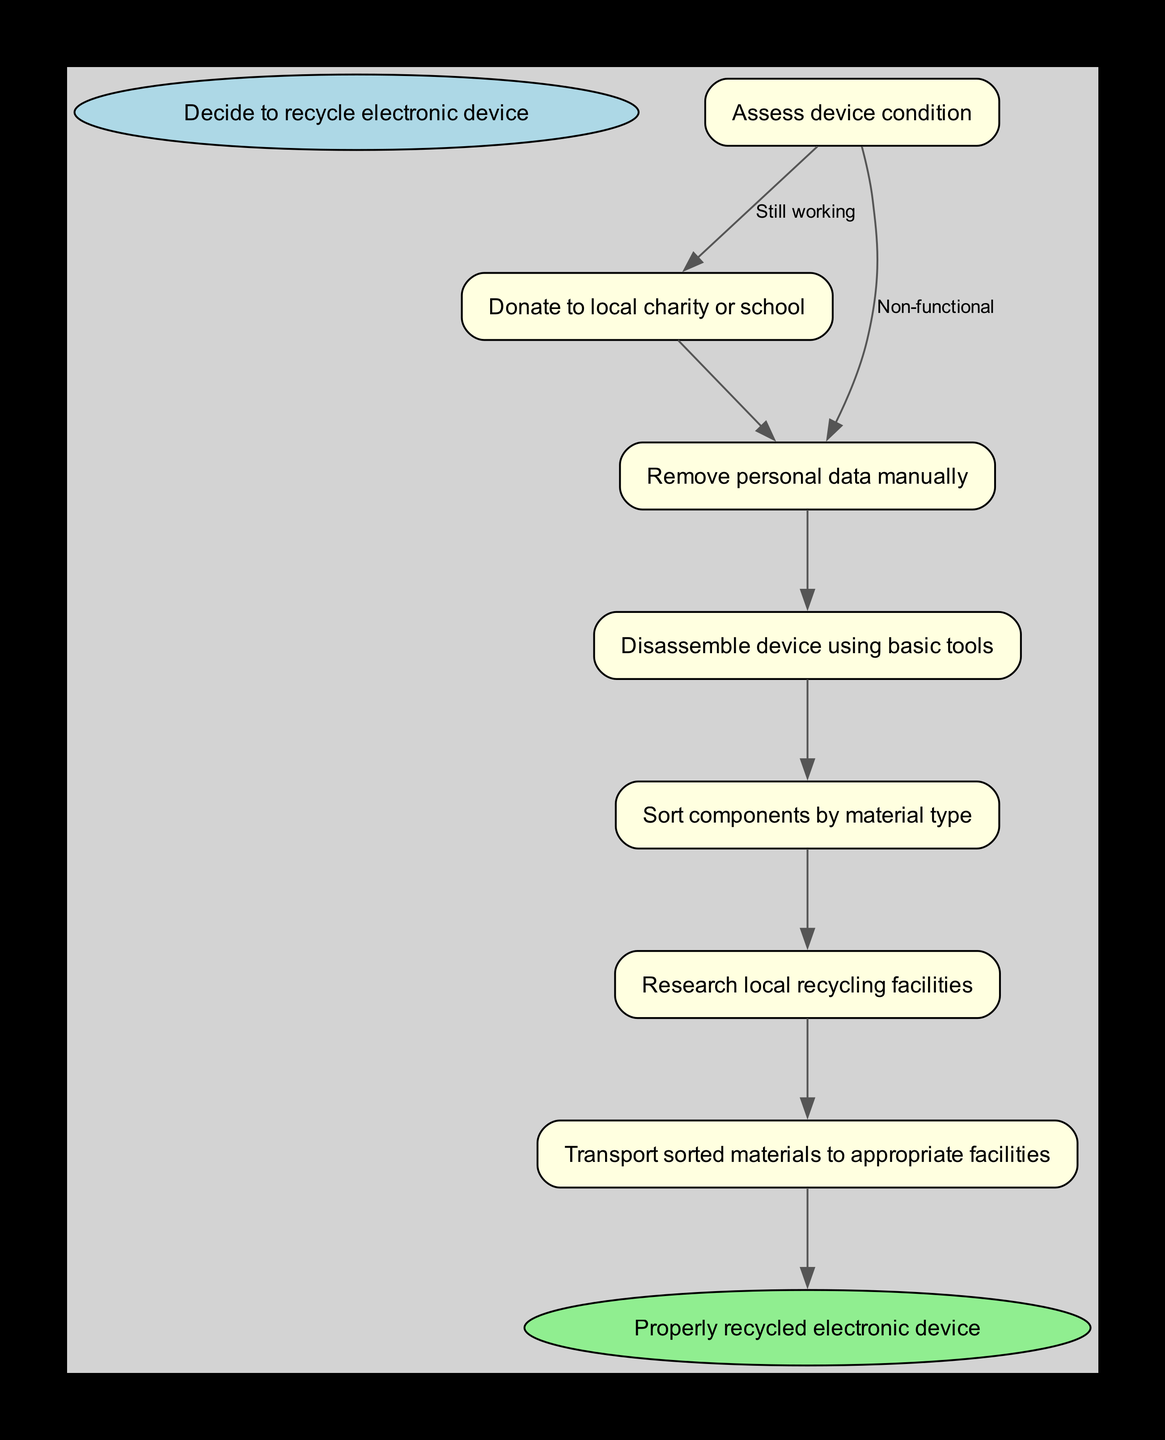What is the first step in this recycling process? The first step is to "Decide to recycle electronic device", which is indicated as the starting point of the flow chart.
Answer: Decide to recycle electronic device How many options do you have after assessing the device condition? After assessing the device condition, there are two options: "Still working" or "Non-functional". This can be confirmed by examining the options listed under the first step.
Answer: Two What should you do if the device is still working? If the device is still working, the next step is to "Donate to local charity or school", which flows directly from the respective node.
Answer: Donate to local charity or school If the device is non-functional, what is the next action after removing personal data? After removing personal data, the next action is to "Disassemble device using basic tools", as it follows sequentially from the non-functional path.
Answer: Disassemble device using basic tools What are the final actions after sorting components by material type? The final actions after sorting components are "Research local recycling facilities" and then "Transport sorted materials to appropriate facilities", which follow sequentially after sorting components.
Answer: Research local recycling facilities and Transport sorted materials to appropriate facilities What is the end result of the recycling process? The end result of the recycling process, as shown in the diagram, is "Properly recycled electronic device", which is connected to the last step in the flow.
Answer: Properly recycled electronic device Which step comes after assessing device condition if it is non-functional? The step that comes after assessing the device condition when it is non-functional is "Remove personal data manually", as indicated by the flow chart's options.
Answer: Remove personal data manually How many steps are there in total, including the start and end? Including the starting point and the end point, there are a total of 8 steps in the flow chart, as indicated by counting each unique step listed.
Answer: Eight 